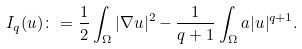<formula> <loc_0><loc_0><loc_500><loc_500>I _ { q } ( u ) \colon = \frac { 1 } { 2 } \int _ { \Omega } | \nabla u | ^ { 2 } - \frac { 1 } { q + 1 } \int _ { \Omega } a | u | ^ { q + 1 } .</formula> 